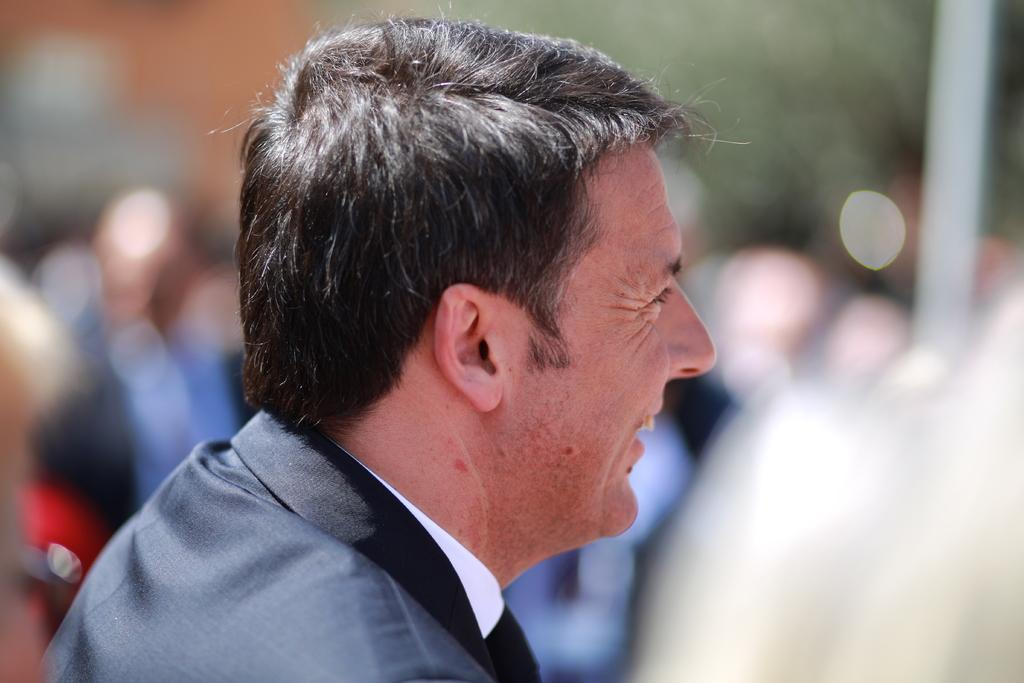What is the main subject of the image? There is a person in the image. Can you describe the background of the image? The background of the image is blurred. What language is the person speaking in the image? There is no information about the language being spoken in the image. What type of seat is the person sitting on in the image? There is no information about a seat or any furniture in the image. 